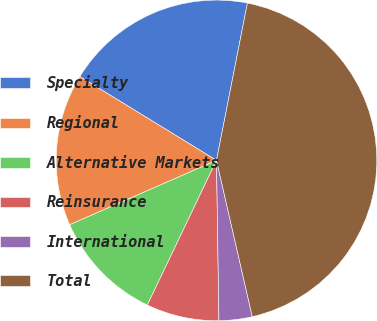Convert chart. <chart><loc_0><loc_0><loc_500><loc_500><pie_chart><fcel>Specialty<fcel>Regional<fcel>Alternative Markets<fcel>Reinsurance<fcel>International<fcel>Total<nl><fcel>19.33%<fcel>15.33%<fcel>11.33%<fcel>7.34%<fcel>3.34%<fcel>43.33%<nl></chart> 